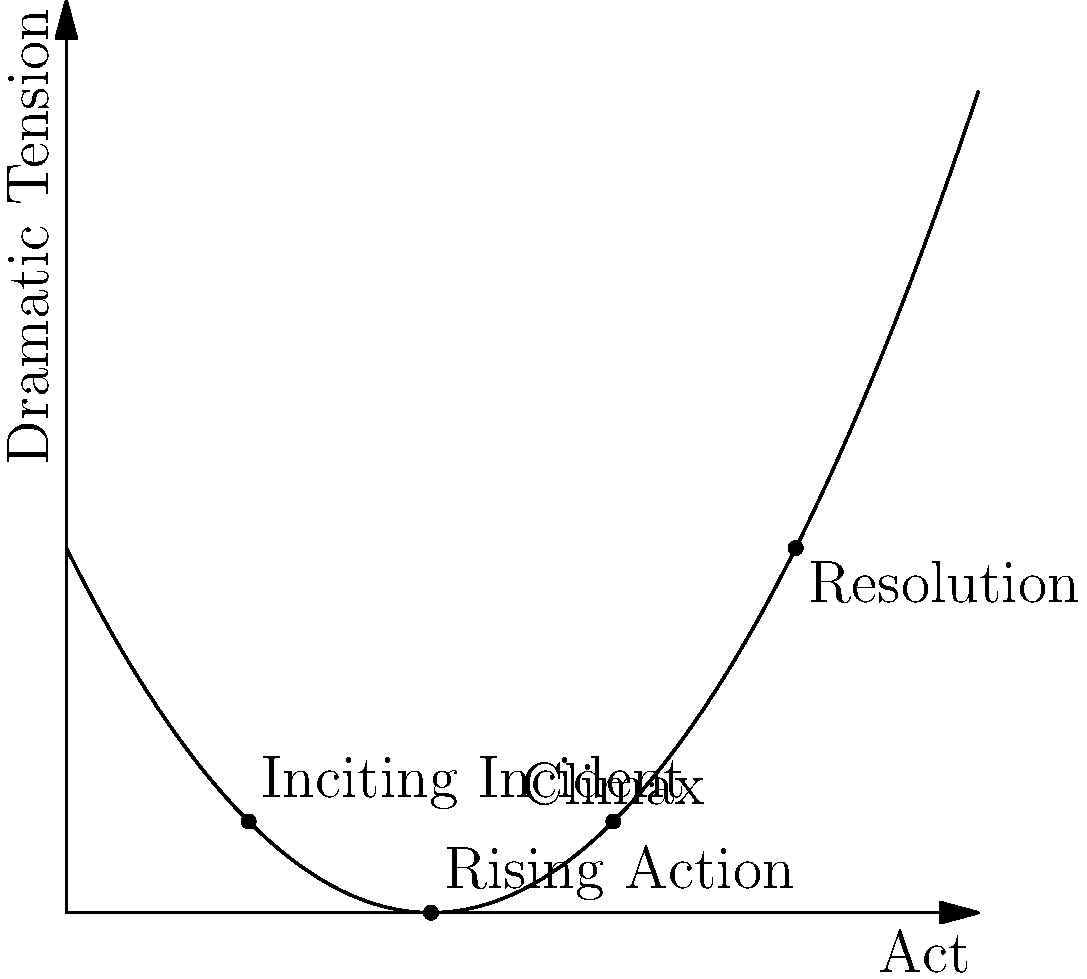Analyzing the curve graph of dramatic tension in a five-act play, which act typically contains the climax, and how does this placement affect the overall dramatic structure? To answer this question, let's analyze the graph step-by-step:

1. The x-axis represents the acts of the play (1-5), while the y-axis represents the level of dramatic tension.

2. The curve shows a parabolic shape, indicating a rise and fall in tension throughout the play.

3. We can identify key plot points marked on the graph:
   - Act 1: Inciting Incident (low tension)
   - Act 2: Rising Action (increasing tension)
   - Act 3: Climax (highest point of tension)
   - Act 4: Resolution (decreasing tension)

4. The climax is clearly positioned at the peak of the curve, corresponding to Act 3.

5. This placement of the climax in Act 3 follows the classical dramatic structure known as Freytag's Pyramid or the dramatic arc.

6. By positioning the climax in Act 3, the playwright creates a balanced structure:
   - Acts 1-2 build tension and develop conflicts
   - Act 3 presents the highest point of conflict
   - Acts 4-5 allow for resolution and denouement

7. This structure affects the overall dramatic tension by:
   - Creating a sense of anticipation as tension builds
   - Providing a clear turning point at the midpoint of the play
   - Allowing sufficient time for resolution without prolonging the tension unnecessarily

8. The placement in Act 3 also typically coincides with the midpoint of the play, creating a symmetrical structure that can be aesthetically pleasing and dramatically satisfying for the audience.
Answer: Act 3; creates a balanced dramatic structure with rising action, peak conflict, and resolution. 